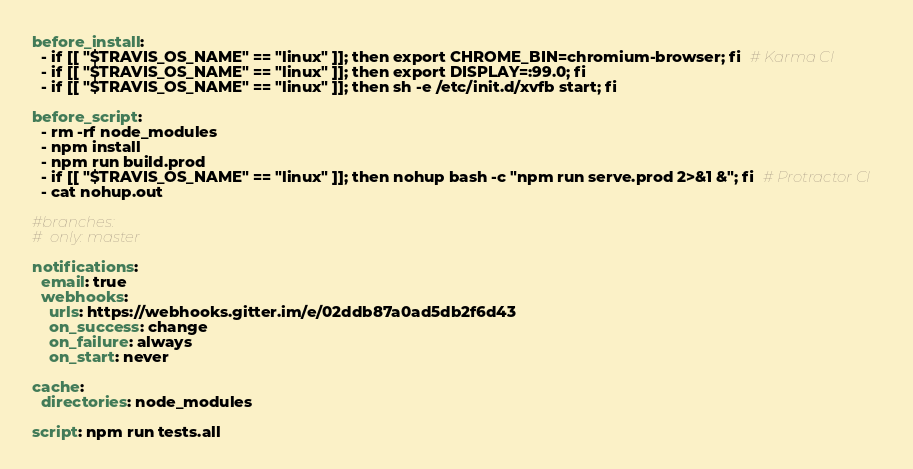<code> <loc_0><loc_0><loc_500><loc_500><_YAML_>
before_install:
  - if [[ "$TRAVIS_OS_NAME" == "linux" ]]; then export CHROME_BIN=chromium-browser; fi  # Karma CI
  - if [[ "$TRAVIS_OS_NAME" == "linux" ]]; then export DISPLAY=:99.0; fi
  - if [[ "$TRAVIS_OS_NAME" == "linux" ]]; then sh -e /etc/init.d/xvfb start; fi

before_script:
  - rm -rf node_modules
  - npm install
  - npm run build.prod
  - if [[ "$TRAVIS_OS_NAME" == "linux" ]]; then nohup bash -c "npm run serve.prod 2>&1 &"; fi  # Protractor CI
  - cat nohup.out

#branches:
#  only: master

notifications:
  email: true
  webhooks:
    urls: https://webhooks.gitter.im/e/02ddb87a0ad5db2f6d43
    on_success: change
    on_failure: always
    on_start: never

cache:
  directories: node_modules

script: npm run tests.all
</code> 